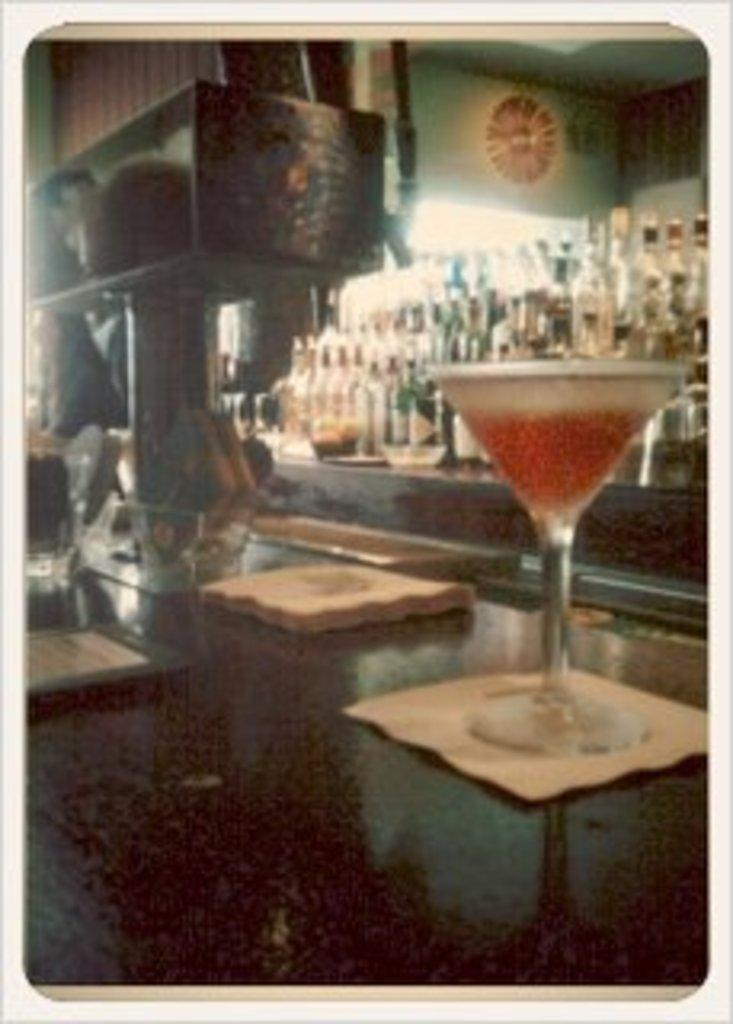What is in the glass that is visible in the image? There is a glass with liquid in the image. Where is the glass located in the image? The glass is on a table in the image. What else can be seen on the table? There are other objects on the table. What can be seen in the background of the image? There are many wine bottles visible in the background. How many copies of the mask are present on the road in the image? There is no mention of a mask or a road in the image; it features a glass with liquid on a table and wine bottles in the background. 